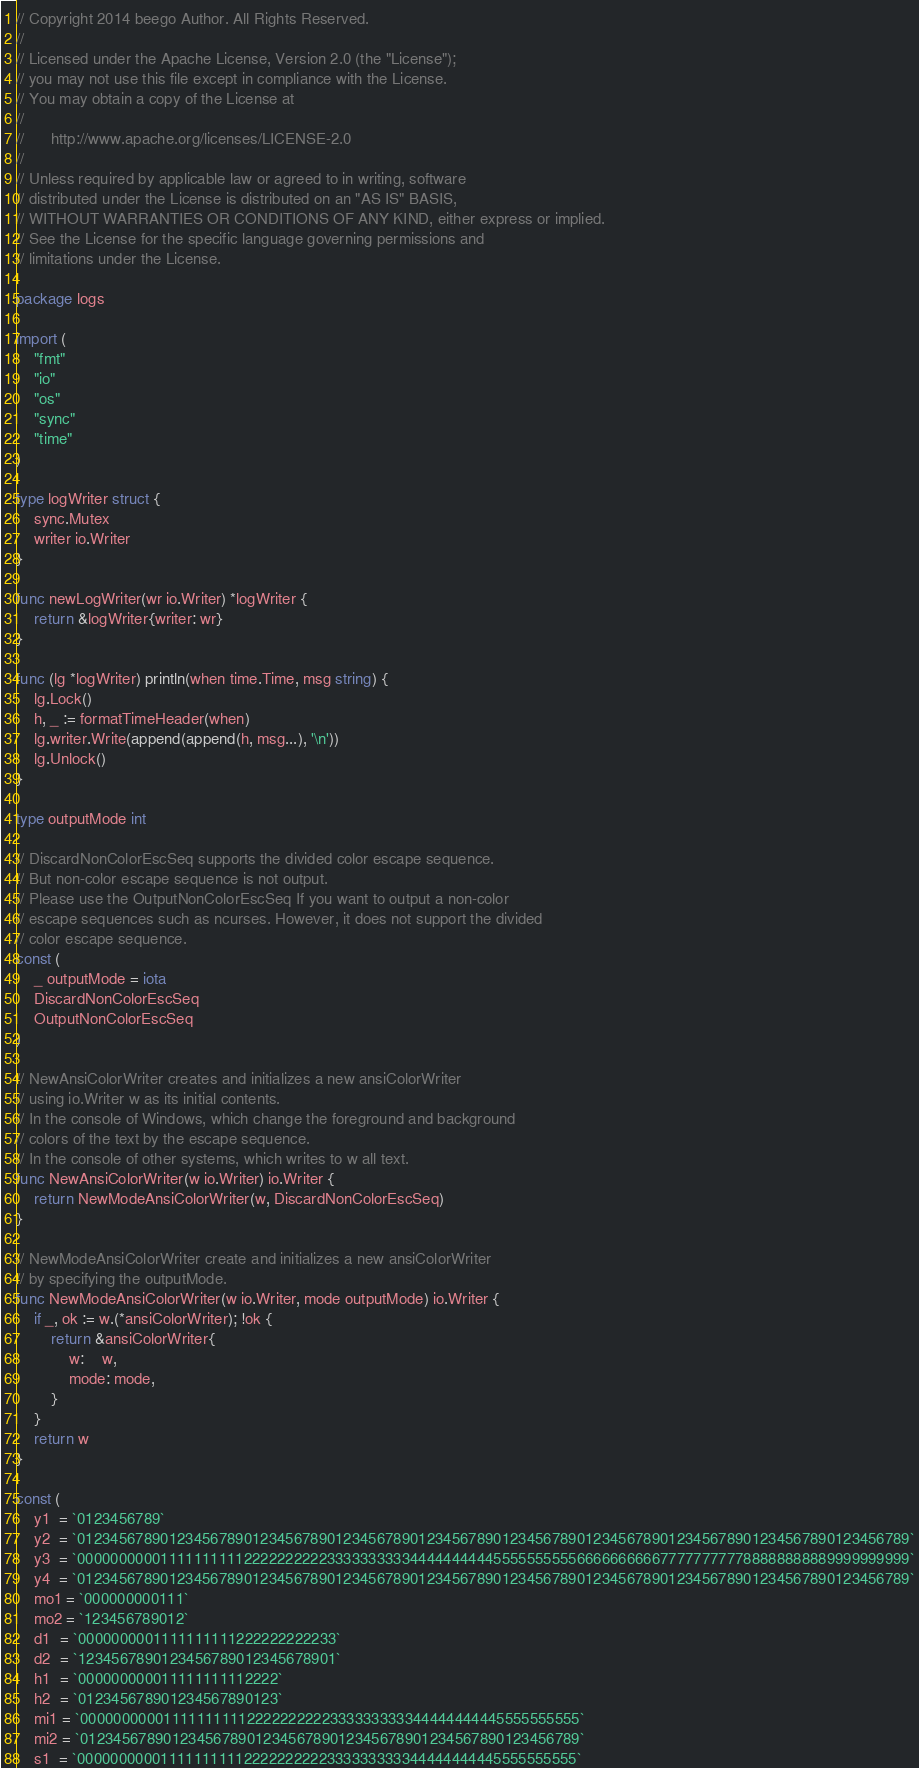<code> <loc_0><loc_0><loc_500><loc_500><_Go_>// Copyright 2014 beego Author. All Rights Reserved.
//
// Licensed under the Apache License, Version 2.0 (the "License");
// you may not use this file except in compliance with the License.
// You may obtain a copy of the License at
//
//      http://www.apache.org/licenses/LICENSE-2.0
//
// Unless required by applicable law or agreed to in writing, software
// distributed under the License is distributed on an "AS IS" BASIS,
// WITHOUT WARRANTIES OR CONDITIONS OF ANY KIND, either express or implied.
// See the License for the specific language governing permissions and
// limitations under the License.

package logs

import (
	"fmt"
	"io"
	"os"
	"sync"
	"time"
)

type logWriter struct {
	sync.Mutex
	writer io.Writer
}

func newLogWriter(wr io.Writer) *logWriter {
	return &logWriter{writer: wr}
}

func (lg *logWriter) println(when time.Time, msg string) {
	lg.Lock()
	h, _ := formatTimeHeader(when)
	lg.writer.Write(append(append(h, msg...), '\n'))
	lg.Unlock()
}

type outputMode int

// DiscardNonColorEscSeq supports the divided color escape sequence.
// But non-color escape sequence is not output.
// Please use the OutputNonColorEscSeq If you want to output a non-color
// escape sequences such as ncurses. However, it does not support the divided
// color escape sequence.
const (
	_ outputMode = iota
	DiscardNonColorEscSeq
	OutputNonColorEscSeq
)

// NewAnsiColorWriter creates and initializes a new ansiColorWriter
// using io.Writer w as its initial contents.
// In the console of Windows, which change the foreground and background
// colors of the text by the escape sequence.
// In the console of other systems, which writes to w all text.
func NewAnsiColorWriter(w io.Writer) io.Writer {
	return NewModeAnsiColorWriter(w, DiscardNonColorEscSeq)
}

// NewModeAnsiColorWriter create and initializes a new ansiColorWriter
// by specifying the outputMode.
func NewModeAnsiColorWriter(w io.Writer, mode outputMode) io.Writer {
	if _, ok := w.(*ansiColorWriter); !ok {
		return &ansiColorWriter{
			w:    w,
			mode: mode,
		}
	}
	return w
}

const (
	y1  = `0123456789`
	y2  = `0123456789012345678901234567890123456789012345678901234567890123456789012345678901234567890123456789`
	y3  = `0000000000111111111122222222223333333333444444444455555555556666666666777777777788888888889999999999`
	y4  = `0123456789012345678901234567890123456789012345678901234567890123456789012345678901234567890123456789`
	mo1 = `000000000111`
	mo2 = `123456789012`
	d1  = `0000000001111111111222222222233`
	d2  = `1234567890123456789012345678901`
	h1  = `000000000011111111112222`
	h2  = `012345678901234567890123`
	mi1 = `000000000011111111112222222222333333333344444444445555555555`
	mi2 = `012345678901234567890123456789012345678901234567890123456789`
	s1  = `000000000011111111112222222222333333333344444444445555555555`</code> 